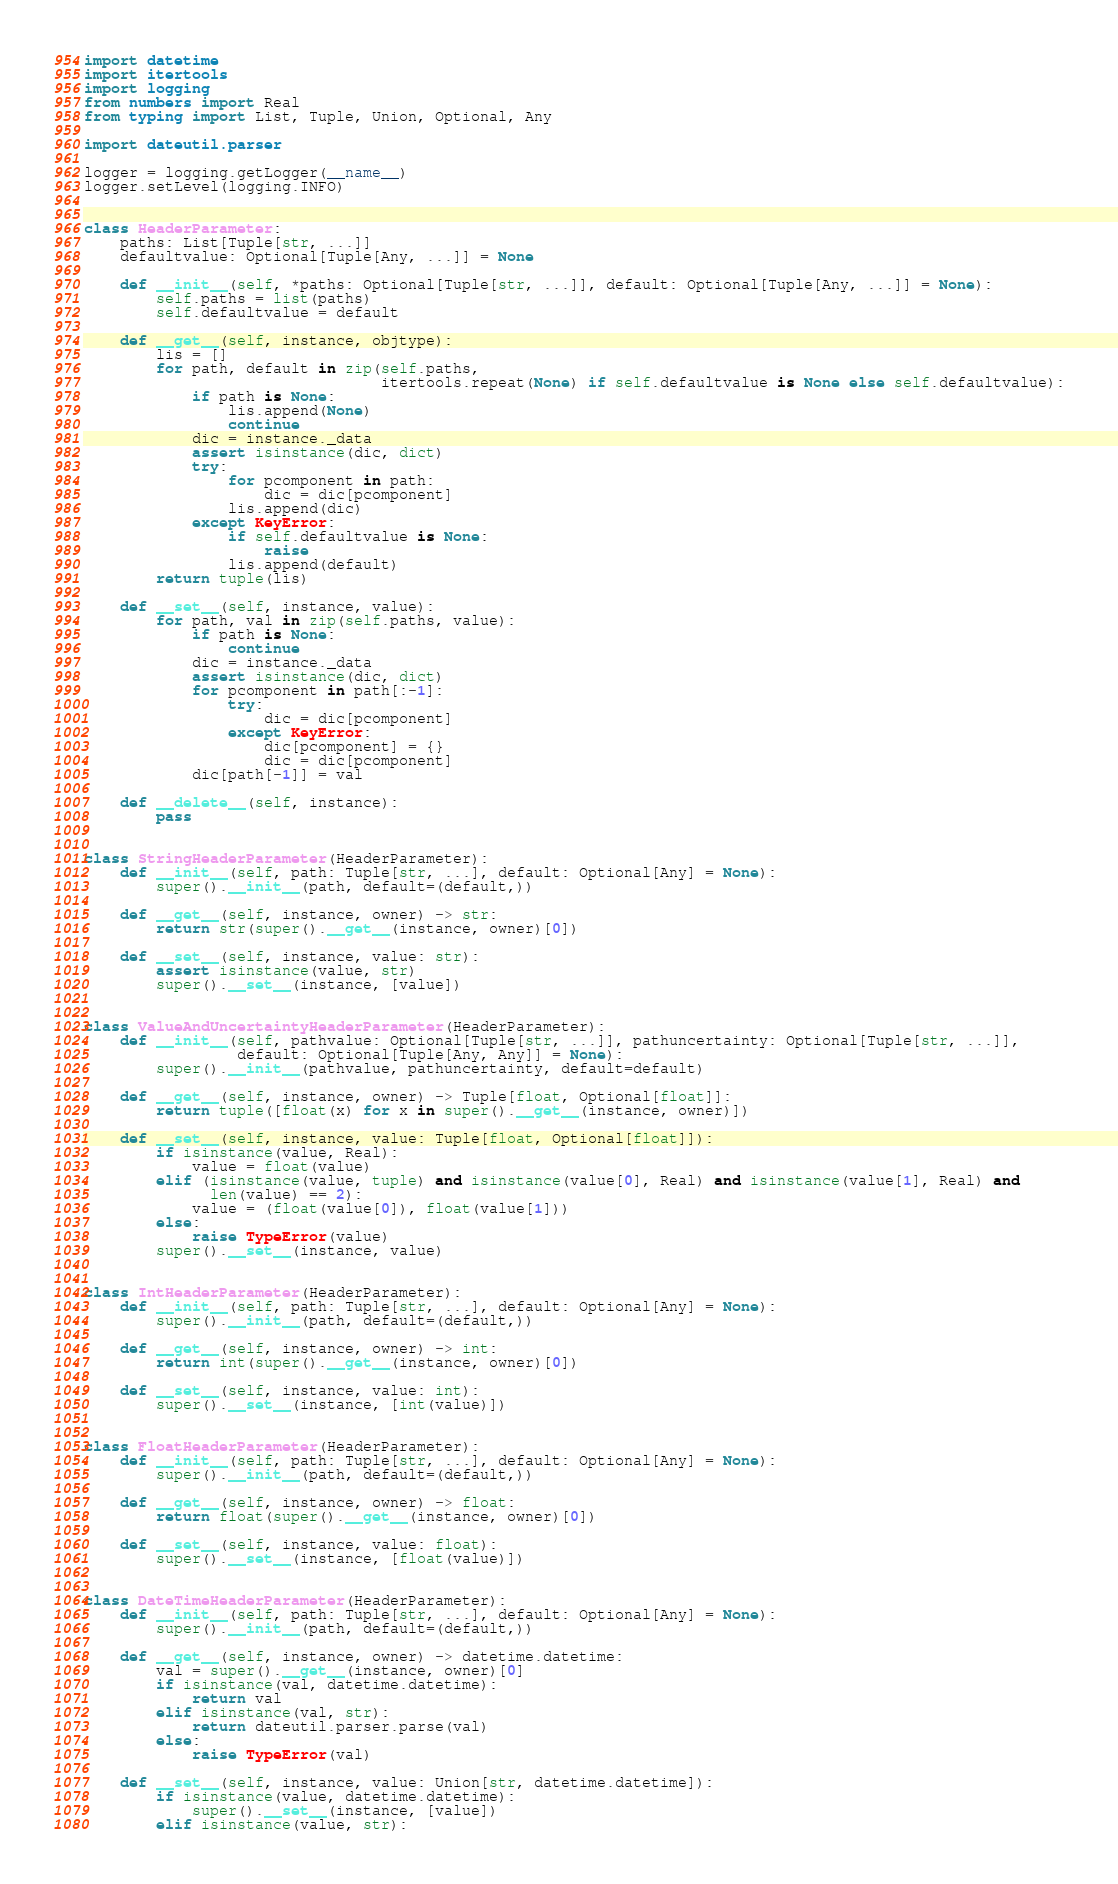Convert code to text. <code><loc_0><loc_0><loc_500><loc_500><_Python_>import datetime
import itertools
import logging
from numbers import Real
from typing import List, Tuple, Union, Optional, Any

import dateutil.parser

logger = logging.getLogger(__name__)
logger.setLevel(logging.INFO)


class HeaderParameter:
    paths: List[Tuple[str, ...]]
    defaultvalue: Optional[Tuple[Any, ...]] = None

    def __init__(self, *paths: Optional[Tuple[str, ...]], default: Optional[Tuple[Any, ...]] = None):
        self.paths = list(paths)
        self.defaultvalue = default

    def __get__(self, instance, objtype):
        lis = []
        for path, default in zip(self.paths,
                                 itertools.repeat(None) if self.defaultvalue is None else self.defaultvalue):
            if path is None:
                lis.append(None)
                continue
            dic = instance._data
            assert isinstance(dic, dict)
            try:
                for pcomponent in path:
                    dic = dic[pcomponent]
                lis.append(dic)
            except KeyError:
                if self.defaultvalue is None:
                    raise
                lis.append(default)
        return tuple(lis)

    def __set__(self, instance, value):
        for path, val in zip(self.paths, value):
            if path is None:
                continue
            dic = instance._data
            assert isinstance(dic, dict)
            for pcomponent in path[:-1]:
                try:
                    dic = dic[pcomponent]
                except KeyError:
                    dic[pcomponent] = {}
                    dic = dic[pcomponent]
            dic[path[-1]] = val

    def __delete__(self, instance):
        pass


class StringHeaderParameter(HeaderParameter):
    def __init__(self, path: Tuple[str, ...], default: Optional[Any] = None):
        super().__init__(path, default=(default,))

    def __get__(self, instance, owner) -> str:
        return str(super().__get__(instance, owner)[0])

    def __set__(self, instance, value: str):
        assert isinstance(value, str)
        super().__set__(instance, [value])


class ValueAndUncertaintyHeaderParameter(HeaderParameter):
    def __init__(self, pathvalue: Optional[Tuple[str, ...]], pathuncertainty: Optional[Tuple[str, ...]],
                 default: Optional[Tuple[Any, Any]] = None):
        super().__init__(pathvalue, pathuncertainty, default=default)

    def __get__(self, instance, owner) -> Tuple[float, Optional[float]]:
        return tuple([float(x) for x in super().__get__(instance, owner)])

    def __set__(self, instance, value: Tuple[float, Optional[float]]):
        if isinstance(value, Real):
            value = float(value)
        elif (isinstance(value, tuple) and isinstance(value[0], Real) and isinstance(value[1], Real) and
              len(value) == 2):
            value = (float(value[0]), float(value[1]))
        else:
            raise TypeError(value)
        super().__set__(instance, value)


class IntHeaderParameter(HeaderParameter):
    def __init__(self, path: Tuple[str, ...], default: Optional[Any] = None):
        super().__init__(path, default=(default,))

    def __get__(self, instance, owner) -> int:
        return int(super().__get__(instance, owner)[0])

    def __set__(self, instance, value: int):
        super().__set__(instance, [int(value)])


class FloatHeaderParameter(HeaderParameter):
    def __init__(self, path: Tuple[str, ...], default: Optional[Any] = None):
        super().__init__(path, default=(default,))

    def __get__(self, instance, owner) -> float:
        return float(super().__get__(instance, owner)[0])

    def __set__(self, instance, value: float):
        super().__set__(instance, [float(value)])


class DateTimeHeaderParameter(HeaderParameter):
    def __init__(self, path: Tuple[str, ...], default: Optional[Any] = None):
        super().__init__(path, default=(default,))

    def __get__(self, instance, owner) -> datetime.datetime:
        val = super().__get__(instance, owner)[0]
        if isinstance(val, datetime.datetime):
            return val
        elif isinstance(val, str):
            return dateutil.parser.parse(val)
        else:
            raise TypeError(val)

    def __set__(self, instance, value: Union[str, datetime.datetime]):
        if isinstance(value, datetime.datetime):
            super().__set__(instance, [value])
        elif isinstance(value, str):</code> 